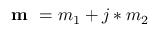<formula> <loc_0><loc_0><loc_500><loc_500>m = m _ { 1 } + j * m _ { 2 }</formula> 